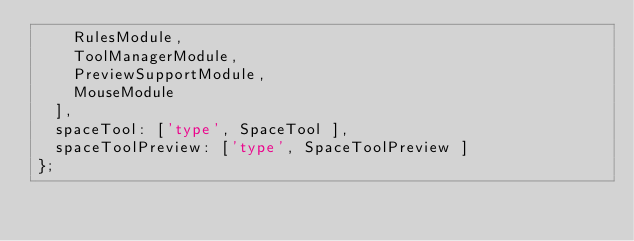<code> <loc_0><loc_0><loc_500><loc_500><_JavaScript_>    RulesModule,
    ToolManagerModule,
    PreviewSupportModule,
    MouseModule
  ],
  spaceTool: ['type', SpaceTool ],
  spaceToolPreview: ['type', SpaceToolPreview ]
};
</code> 